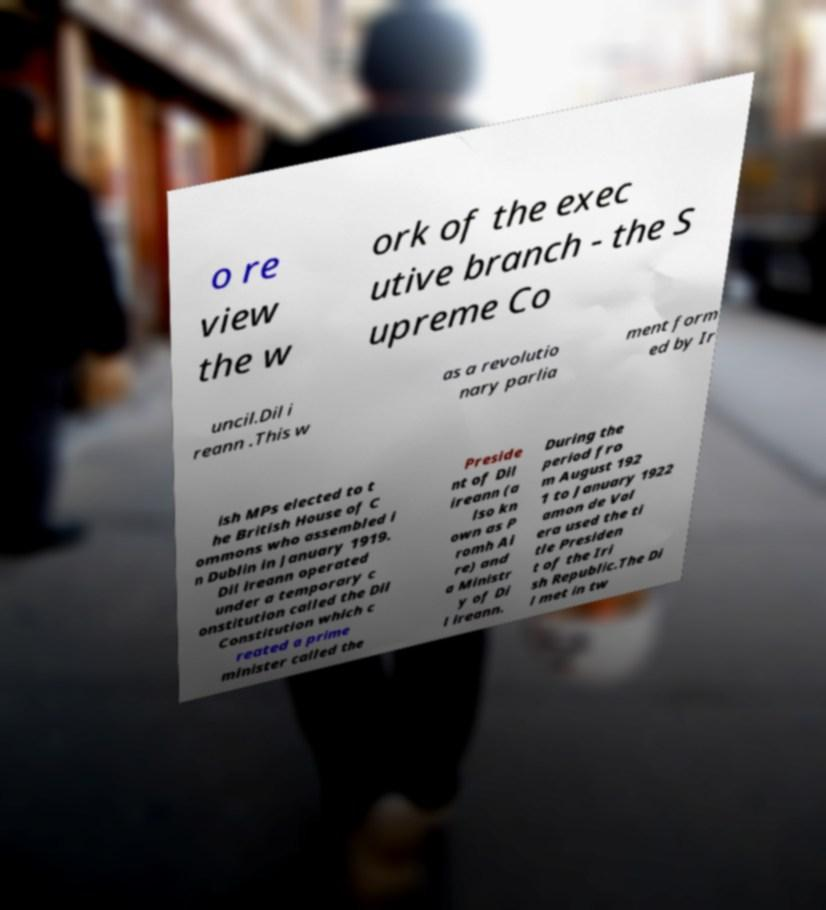I need the written content from this picture converted into text. Can you do that? o re view the w ork of the exec utive branch - the S upreme Co uncil.Dil i reann .This w as a revolutio nary parlia ment form ed by Ir ish MPs elected to t he British House of C ommons who assembled i n Dublin in January 1919. Dil ireann operated under a temporary c onstitution called the Dil Constitution which c reated a prime minister called the Preside nt of Dil ireann (a lso kn own as P romh Ai re) and a Ministr y of Di l ireann. During the period fro m August 192 1 to January 1922 amon de Val era used the ti tle Presiden t of the Iri sh Republic.The Di l met in tw 